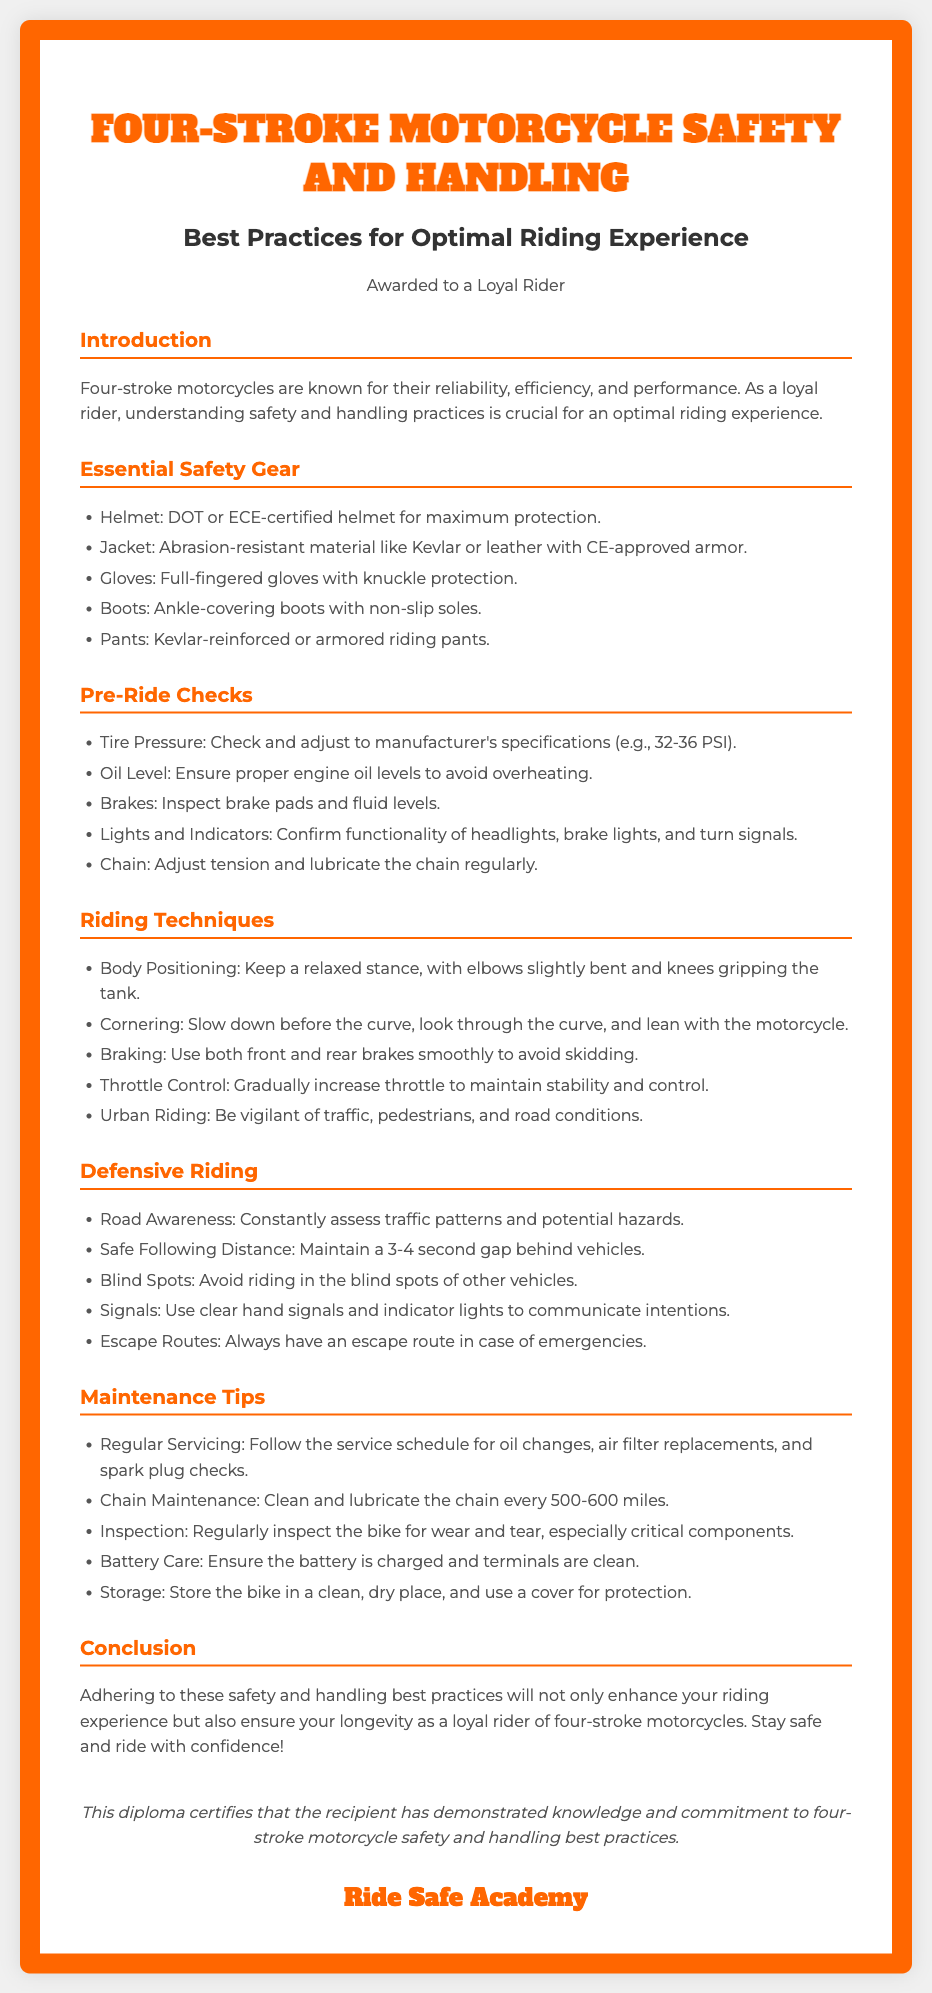What are some essential safety gears for four-stroke motorcycles? Essential safety gear includes a helmet, jacket, gloves, boots, and pants.
Answer: Helmet, jacket, gloves, boots, pants What is the ideal tire pressure range mentioned? The document specifies that the ideal tire pressure should be adjusted to the manufacturer's specifications, which is generally between 32-36 PSI.
Answer: 32-36 PSI What should be checked regarding the brakes? The document states that brake pads and fluid levels should be inspected.
Answer: Brake pads and fluid levels How should one position their body while riding? The appropriate body positioning involves keeping a relaxed stance with elbows slightly bent and knees gripping the tank.
Answer: Relaxed stance, elbows bent, knees gripping What is a recommended safe following distance? The document suggests maintaining a following distance of 3-4 seconds behind vehicles for safety.
Answer: 3-4 seconds What is the maximum recommended frequency for chain maintenance? According to the document, the chain should be cleaned and lubricated every 500-600 miles.
Answer: Every 500-600 miles Which organization issued this diploma? The diploma is certified by "Ride Safe Academy."
Answer: Ride Safe Academy What is the purpose of this diploma? The purpose of the diploma is to certify that the recipient has demonstrated knowledge and commitment to motorcycle safety and handling best practices.
Answer: Knowledge and commitment to safety and handling best practices 